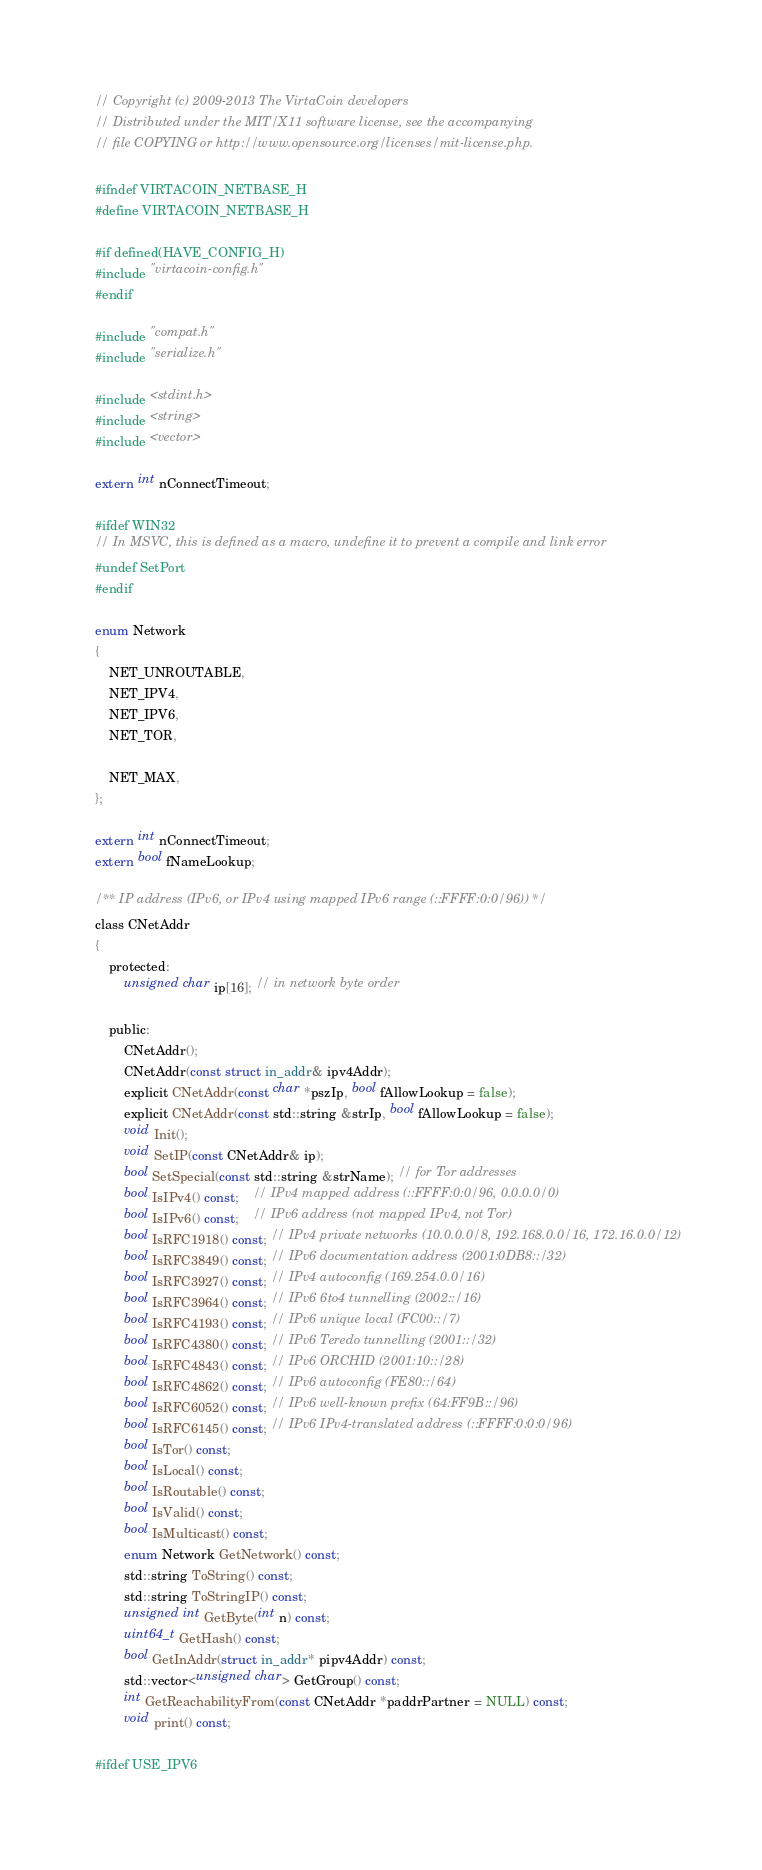<code> <loc_0><loc_0><loc_500><loc_500><_C_>// Copyright (c) 2009-2013 The VirtaCoin developers
// Distributed under the MIT/X11 software license, see the accompanying
// file COPYING or http://www.opensource.org/licenses/mit-license.php.

#ifndef VIRTACOIN_NETBASE_H
#define VIRTACOIN_NETBASE_H

#if defined(HAVE_CONFIG_H)
#include "virtacoin-config.h"
#endif

#include "compat.h"
#include "serialize.h"

#include <stdint.h>
#include <string>
#include <vector>

extern int nConnectTimeout;

#ifdef WIN32
// In MSVC, this is defined as a macro, undefine it to prevent a compile and link error
#undef SetPort
#endif

enum Network
{
    NET_UNROUTABLE,
    NET_IPV4,
    NET_IPV6,
    NET_TOR,

    NET_MAX,
};

extern int nConnectTimeout;
extern bool fNameLookup;

/** IP address (IPv6, or IPv4 using mapped IPv6 range (::FFFF:0:0/96)) */
class CNetAddr
{
    protected:
        unsigned char ip[16]; // in network byte order

    public:
        CNetAddr();
        CNetAddr(const struct in_addr& ipv4Addr);
        explicit CNetAddr(const char *pszIp, bool fAllowLookup = false);
        explicit CNetAddr(const std::string &strIp, bool fAllowLookup = false);
        void Init();
        void SetIP(const CNetAddr& ip);
        bool SetSpecial(const std::string &strName); // for Tor addresses
        bool IsIPv4() const;    // IPv4 mapped address (::FFFF:0:0/96, 0.0.0.0/0)
        bool IsIPv6() const;    // IPv6 address (not mapped IPv4, not Tor)
        bool IsRFC1918() const; // IPv4 private networks (10.0.0.0/8, 192.168.0.0/16, 172.16.0.0/12)
        bool IsRFC3849() const; // IPv6 documentation address (2001:0DB8::/32)
        bool IsRFC3927() const; // IPv4 autoconfig (169.254.0.0/16)
        bool IsRFC3964() const; // IPv6 6to4 tunnelling (2002::/16)
        bool IsRFC4193() const; // IPv6 unique local (FC00::/7)
        bool IsRFC4380() const; // IPv6 Teredo tunnelling (2001::/32)
        bool IsRFC4843() const; // IPv6 ORCHID (2001:10::/28)
        bool IsRFC4862() const; // IPv6 autoconfig (FE80::/64)
        bool IsRFC6052() const; // IPv6 well-known prefix (64:FF9B::/96)
        bool IsRFC6145() const; // IPv6 IPv4-translated address (::FFFF:0:0:0/96)
        bool IsTor() const;
        bool IsLocal() const;
        bool IsRoutable() const;
        bool IsValid() const;
        bool IsMulticast() const;
        enum Network GetNetwork() const;
        std::string ToString() const;
        std::string ToStringIP() const;
        unsigned int GetByte(int n) const;
        uint64_t GetHash() const;
        bool GetInAddr(struct in_addr* pipv4Addr) const;
        std::vector<unsigned char> GetGroup() const;
        int GetReachabilityFrom(const CNetAddr *paddrPartner = NULL) const;
        void print() const;

#ifdef USE_IPV6</code> 